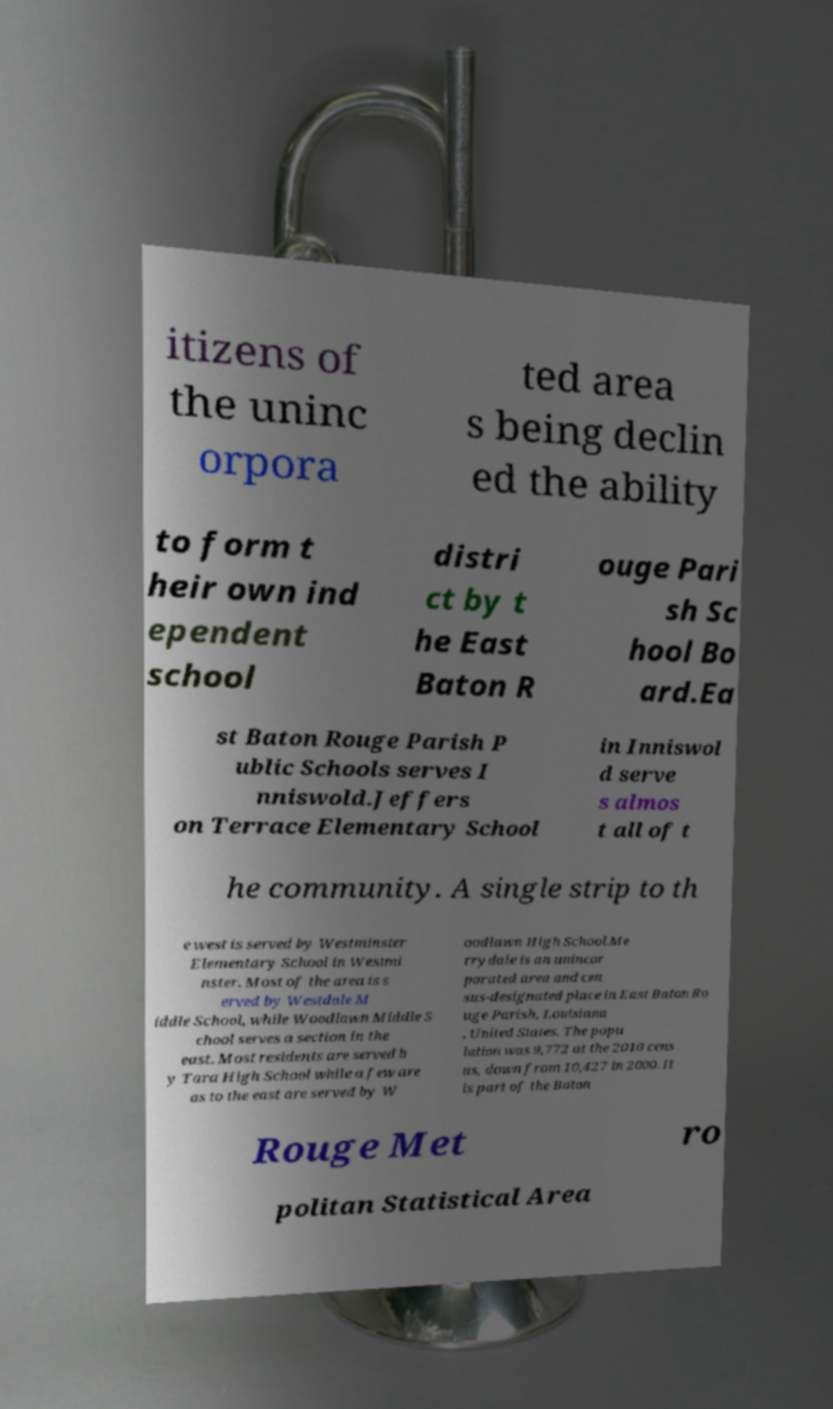For documentation purposes, I need the text within this image transcribed. Could you provide that? itizens of the uninc orpora ted area s being declin ed the ability to form t heir own ind ependent school distri ct by t he East Baton R ouge Pari sh Sc hool Bo ard.Ea st Baton Rouge Parish P ublic Schools serves I nniswold.Jeffers on Terrace Elementary School in Inniswol d serve s almos t all of t he community. A single strip to th e west is served by Westminster Elementary School in Westmi nster. Most of the area is s erved by Westdale M iddle School, while Woodlawn Middle S chool serves a section in the east. Most residents are served b y Tara High School while a few are as to the east are served by W oodlawn High School.Me rrydale is an unincor porated area and cen sus-designated place in East Baton Ro uge Parish, Louisiana , United States. The popu lation was 9,772 at the 2010 cens us, down from 10,427 in 2000. It is part of the Baton Rouge Met ro politan Statistical Area 